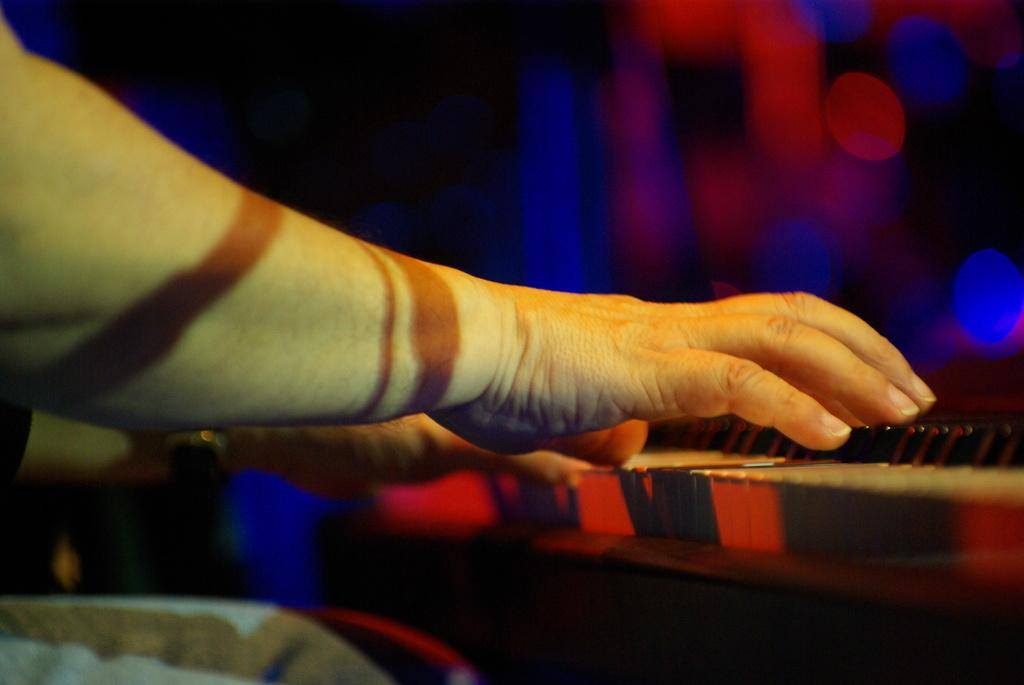What is the main subject of the image? There is a person in the image. What is the person doing in the image? The person is playing the piano. What type of impulse can be seen affecting the chain in the image? There is no chain present in the image, so it is not possible to determine if any impulse is affecting it. 